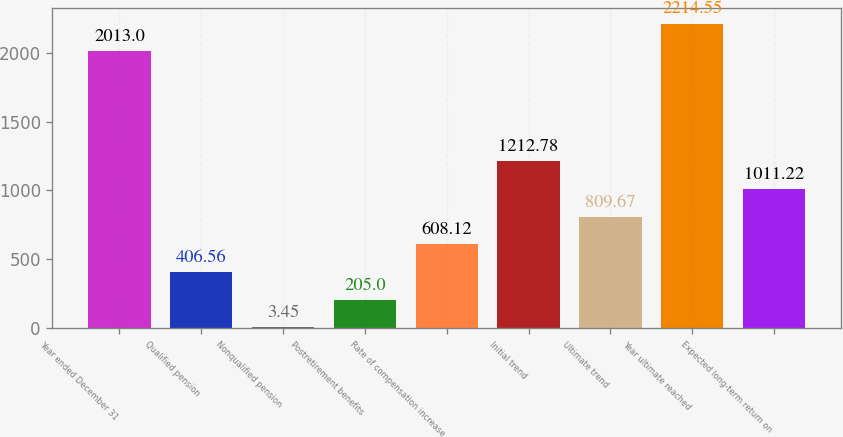Convert chart. <chart><loc_0><loc_0><loc_500><loc_500><bar_chart><fcel>Year ended December 31<fcel>Qualified pension<fcel>Nonqualified pension<fcel>Postretirement benefits<fcel>Rate of compensation increase<fcel>Initial trend<fcel>Ultimate trend<fcel>Year ultimate reached<fcel>Expected long-term return on<nl><fcel>2013<fcel>406.56<fcel>3.45<fcel>205<fcel>608.12<fcel>1212.78<fcel>809.67<fcel>2214.55<fcel>1011.22<nl></chart> 